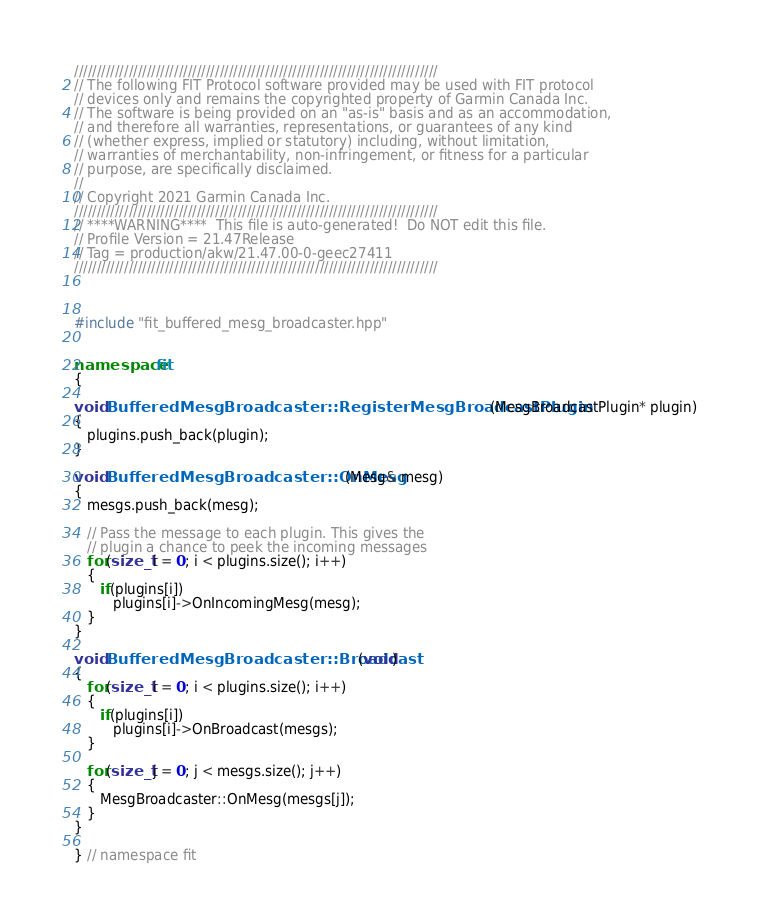<code> <loc_0><loc_0><loc_500><loc_500><_C++_>////////////////////////////////////////////////////////////////////////////////
// The following FIT Protocol software provided may be used with FIT protocol
// devices only and remains the copyrighted property of Garmin Canada Inc.
// The software is being provided on an "as-is" basis and as an accommodation,
// and therefore all warranties, representations, or guarantees of any kind
// (whether express, implied or statutory) including, without limitation,
// warranties of merchantability, non-infringement, or fitness for a particular
// purpose, are specifically disclaimed.
//
// Copyright 2021 Garmin Canada Inc.
////////////////////////////////////////////////////////////////////////////////
// ****WARNING****  This file is auto-generated!  Do NOT edit this file.
// Profile Version = 21.47Release
// Tag = production/akw/21.47.00-0-geec27411
////////////////////////////////////////////////////////////////////////////////



#include "fit_buffered_mesg_broadcaster.hpp"


namespace fit
{

void BufferedMesgBroadcaster::RegisterMesgBroadcastPlugin(MesgBroadcastPlugin* plugin)
{
   plugins.push_back(plugin);
}

void BufferedMesgBroadcaster::OnMesg(Mesg& mesg)
{
   mesgs.push_back(mesg);

   // Pass the message to each plugin. This gives the
   // plugin a chance to peek the incoming messages
   for(size_t i = 0; i < plugins.size(); i++)
   {
      if(plugins[i])
         plugins[i]->OnIncomingMesg(mesg);
   }
}

void BufferedMesgBroadcaster::Broadcast(void)
{
   for(size_t i = 0; i < plugins.size(); i++)
   {
      if(plugins[i])
         plugins[i]->OnBroadcast(mesgs);
   }

   for(size_t j = 0; j < mesgs.size(); j++)
   {
      MesgBroadcaster::OnMesg(mesgs[j]);
   }
}

} // namespace fit
</code> 